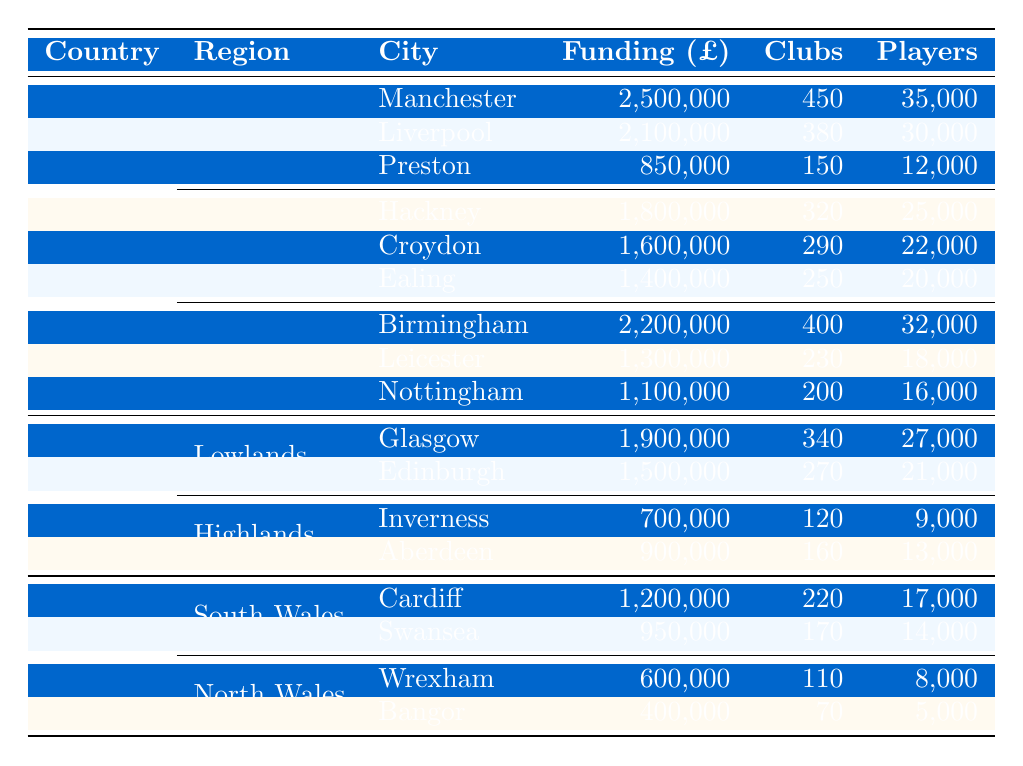What is the total funding for the clubs in the North West region? In the North West region, the funding amounts are £2,500,000 for Manchester, £2,100,000 for Liverpool, and £850,000 for Preston. Summing these amounts gives £2,500,000 + £2,100,000 + £850,000 = £5,450,000.
Answer: £5,450,000 Which city in the Midlands has the highest number of players? In the Midlands, Birmingham has 32,000 players, Leicester has 18,000 players, and Nottingham has 16,000 players. Comparing these numbers, Birmingham has the highest total.
Answer: Birmingham Is the funding for clubs in Scotland higher than for clubs in Wales? Total funding for Scotland is £1,900,000 (Glasgow) + £1,500,000 (Edinburgh) + £700,000 (Inverness) + £900,000 (Aberdeen) = £5,000,000. Total funding for Wales is £1,200,000 (Cardiff) + £950,000 (Swansea) + £600,000 (Wrexham) + £400,000 (Bangor) = £3,150,000. Since £5,000,000 > £3,150,000, funding in Scotland is higher.
Answer: Yes What is the average funding per club in London? The total funding for London is £1,800,000 + £1,600,000 + £1,400,000 = £4,800,000, and the total number of clubs is 320 + 290 + 250 = 860. The average funding per club is £4,800,000 / 860 = approximately £5,581.40.
Answer: £5,581.40 How many more clubs are there in the North West than in Scotland's Lowlands? In the North West, the total number of clubs is 450 (Manchester) + 380 (Liverpool) + 150 (Preston) = 980. In Scotland's Lowlands, the clubs total 340 (Glasgow) + 270 (Edinburgh) = 610. The difference is 980 - 610 = 370 more clubs in the North West.
Answer: 370 Which region has the fewest players overall? For Wales, the total players are 17,000 (Cardiff) + 14,000 (Swansea) + 8,000 (Wrexham) + 5,000 (Bangor) = 44,000. For Scotland, the total players are 27,000 (Glasgow) + 21,000 (Edinburgh) + 9,000 (Inverness) + 13,000 (Aberdeen) = 70,000. For the North West, total players are 35,000 (Manchester) + 30,000 (Liverpool) + 12,000 (Preston) = 77,000. For London, total players are 25,000 (Hackney) + 22,000 (Croydon) + 20,000 (Ealing) = 67,000. Comparing these totals, Wales has the fewest players.
Answer: Wales Does Manchester have more players than any city in Scotland? Manchester has 35,000 players. In Scotland, Glasgow has 27,000 players and Edinburgh has 21,000 players. Since 35,000 > 27,000 and 35,000 > 21,000, it is true that Manchester has more players.
Answer: Yes 